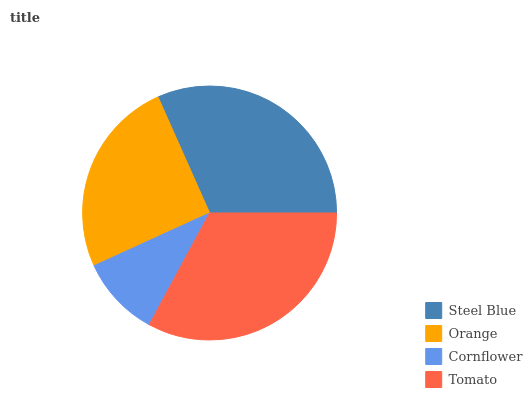Is Cornflower the minimum?
Answer yes or no. Yes. Is Tomato the maximum?
Answer yes or no. Yes. Is Orange the minimum?
Answer yes or no. No. Is Orange the maximum?
Answer yes or no. No. Is Steel Blue greater than Orange?
Answer yes or no. Yes. Is Orange less than Steel Blue?
Answer yes or no. Yes. Is Orange greater than Steel Blue?
Answer yes or no. No. Is Steel Blue less than Orange?
Answer yes or no. No. Is Steel Blue the high median?
Answer yes or no. Yes. Is Orange the low median?
Answer yes or no. Yes. Is Orange the high median?
Answer yes or no. No. Is Tomato the low median?
Answer yes or no. No. 